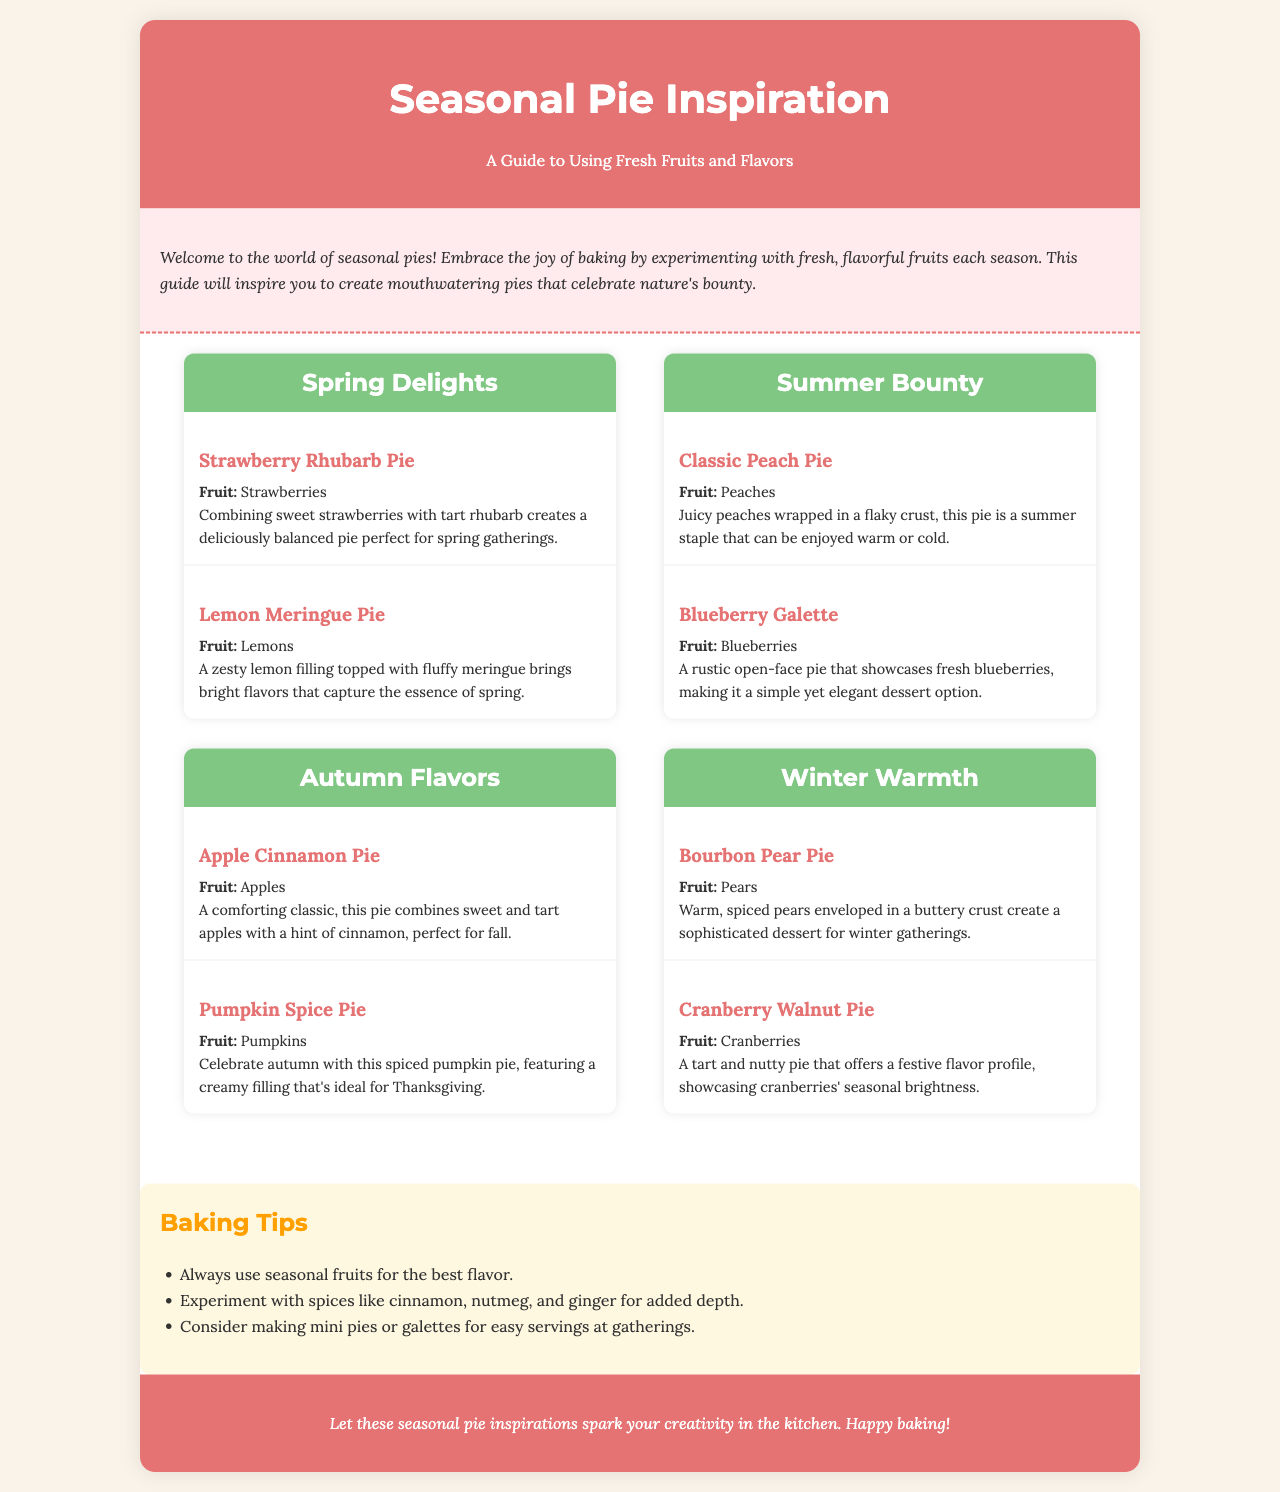What pie features strawberries? The pie that features strawberries is the Strawberry Rhubarb Pie.
Answer: Strawberry Rhubarb Pie Which season is the Lemon Meringue Pie associated with? The Lemon Meringue Pie is associated with the spring season.
Answer: Spring What is one ingredient highlighted in the Winter Warmth section? The ingredient highlighted in the Winter Warmth section is pears in the Bourbon Pear Pie.
Answer: Pears How many pies are listed under Summer Bounty? There are two pies listed under Summer Bounty.
Answer: 2 What type of pie is a Blueberry Galette? The Blueberry Galette is described as a rustic open-face pie.
Answer: Rustic open-face pie What flavor is combined with apples in the Apple Cinnamon Pie? The flavor combined with apples in the Apple Cinnamon Pie is cinnamon.
Answer: Cinnamon What is a suggested baking tip mentioned in the brochure? One suggested baking tip is to always use seasonal fruits for the best flavor.
Answer: Use seasonal fruits Which pie captures the essence of spring? The pie that captures the essence of spring is Lemon Meringue Pie.
Answer: Lemon Meringue Pie What season features pumpkin as a key ingredient? The season that features pumpkin as a key ingredient is autumn.
Answer: Autumn 